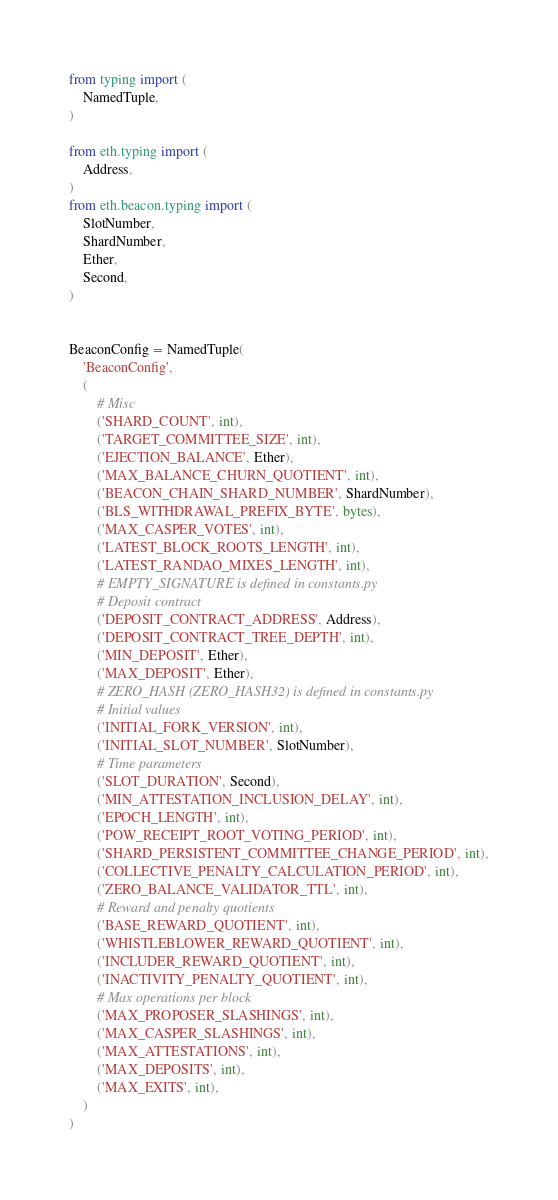Convert code to text. <code><loc_0><loc_0><loc_500><loc_500><_Python_>from typing import (
    NamedTuple,
)

from eth.typing import (
    Address,
)
from eth.beacon.typing import (
    SlotNumber,
    ShardNumber,
    Ether,
    Second,
)


BeaconConfig = NamedTuple(
    'BeaconConfig',
    (
        # Misc
        ('SHARD_COUNT', int),
        ('TARGET_COMMITTEE_SIZE', int),
        ('EJECTION_BALANCE', Ether),
        ('MAX_BALANCE_CHURN_QUOTIENT', int),
        ('BEACON_CHAIN_SHARD_NUMBER', ShardNumber),
        ('BLS_WITHDRAWAL_PREFIX_BYTE', bytes),
        ('MAX_CASPER_VOTES', int),
        ('LATEST_BLOCK_ROOTS_LENGTH', int),
        ('LATEST_RANDAO_MIXES_LENGTH', int),
        # EMPTY_SIGNATURE is defined in constants.py
        # Deposit contract
        ('DEPOSIT_CONTRACT_ADDRESS', Address),
        ('DEPOSIT_CONTRACT_TREE_DEPTH', int),
        ('MIN_DEPOSIT', Ether),
        ('MAX_DEPOSIT', Ether),
        # ZERO_HASH (ZERO_HASH32) is defined in constants.py
        # Initial values
        ('INITIAL_FORK_VERSION', int),
        ('INITIAL_SLOT_NUMBER', SlotNumber),
        # Time parameters
        ('SLOT_DURATION', Second),
        ('MIN_ATTESTATION_INCLUSION_DELAY', int),
        ('EPOCH_LENGTH', int),
        ('POW_RECEIPT_ROOT_VOTING_PERIOD', int),
        ('SHARD_PERSISTENT_COMMITTEE_CHANGE_PERIOD', int),
        ('COLLECTIVE_PENALTY_CALCULATION_PERIOD', int),
        ('ZERO_BALANCE_VALIDATOR_TTL', int),
        # Reward and penalty quotients
        ('BASE_REWARD_QUOTIENT', int),
        ('WHISTLEBLOWER_REWARD_QUOTIENT', int),
        ('INCLUDER_REWARD_QUOTIENT', int),
        ('INACTIVITY_PENALTY_QUOTIENT', int),
        # Max operations per block
        ('MAX_PROPOSER_SLASHINGS', int),
        ('MAX_CASPER_SLASHINGS', int),
        ('MAX_ATTESTATIONS', int),
        ('MAX_DEPOSITS', int),
        ('MAX_EXITS', int),
    )
)
</code> 